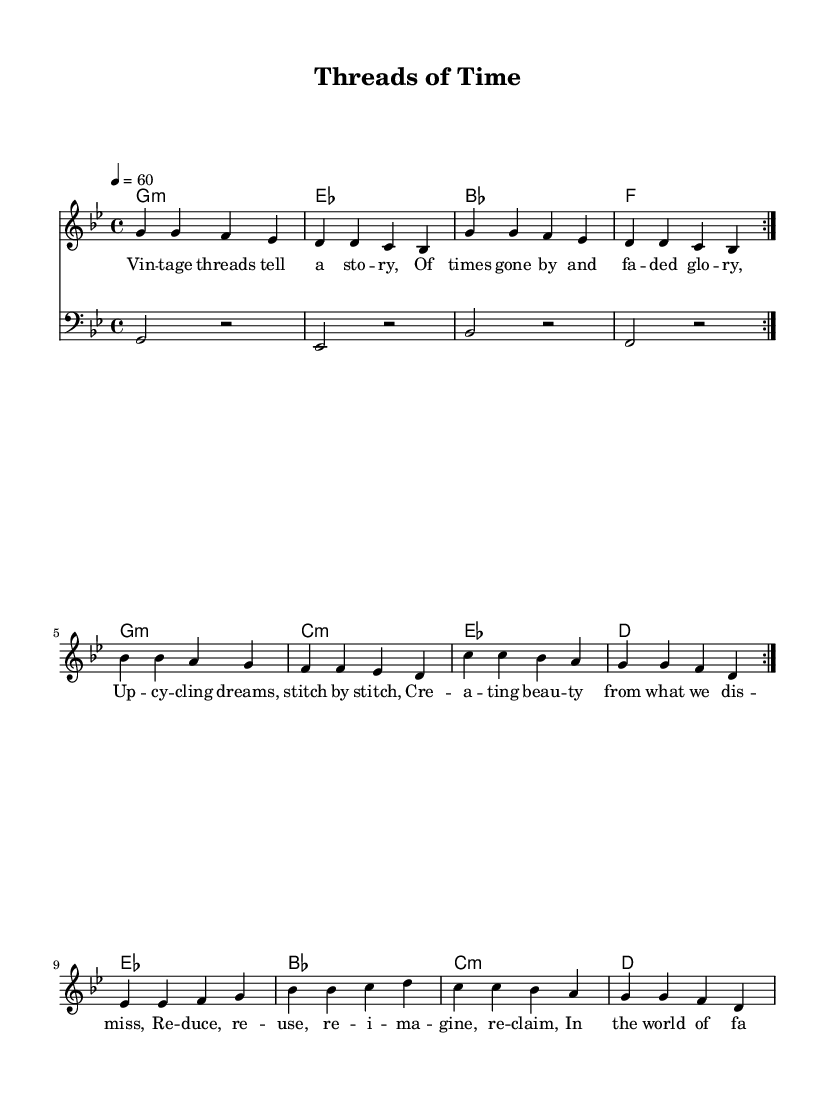What is the key signature of this music? The key signature is G minor, which is indicated by two flats (B flat and E flat).
Answer: G minor What is the time signature of this music? The time signature shown is 4/4, indicating four beats per measure.
Answer: 4/4 What is the tempo indicated in the music? The tempo marked is 60 beats per minute, which means the music is played at a slow and steady pace.
Answer: 60 How many measures are repeated in the melody? The melody specifies two repetitions of the section, as indicated by the "volta" marking.
Answer: 2 What is the first chord in the harmony section? The first chord in the harmony section is G minor, as indicated at the beginning of the chord sequence.
Answer: G minor What is the lyrical theme of this song? The lyrics discuss themes of upcycling and sustainable fashion, focusing on creating beauty from dismissed items.
Answer: Upcycling How does the bassline relate to the melody? The bassline provides a foundation that complements the melody with a rhythmic and harmonic structure, mainly on the tonic and dominant notes.
Answer: Complementary 